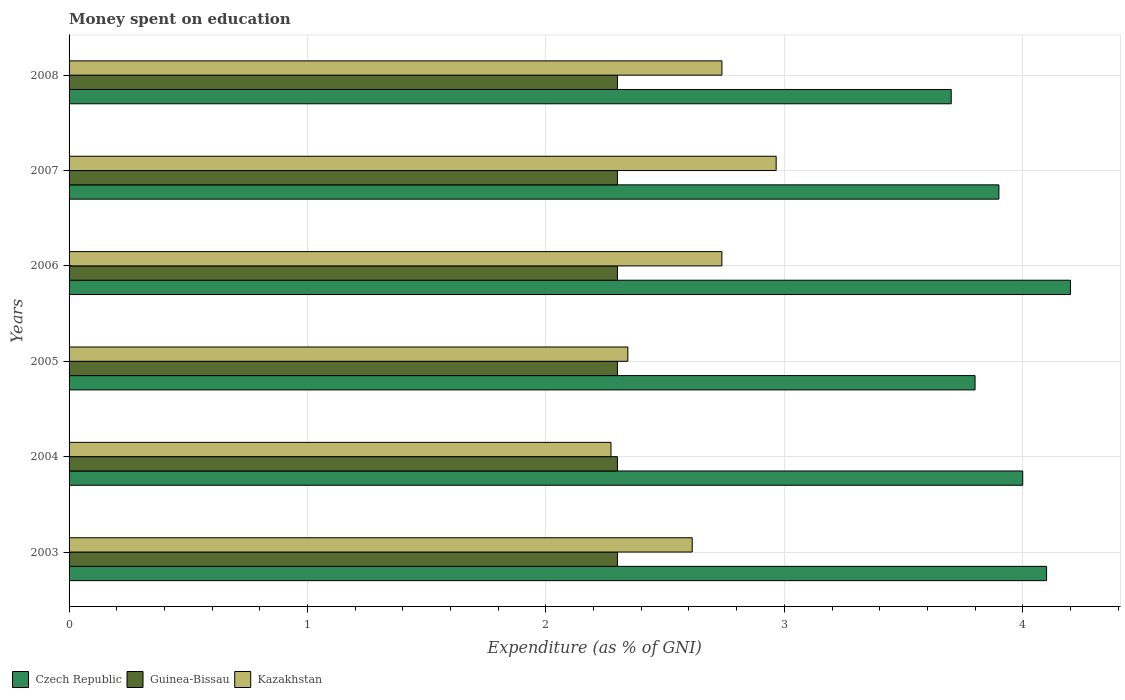How many different coloured bars are there?
Offer a terse response. 3. How many groups of bars are there?
Your answer should be very brief. 6. Are the number of bars on each tick of the Y-axis equal?
Give a very brief answer. Yes. What is the label of the 3rd group of bars from the top?
Your response must be concise. 2006. What is the amount of money spent on education in Czech Republic in 2003?
Your response must be concise. 4.1. In which year was the amount of money spent on education in Guinea-Bissau minimum?
Provide a short and direct response. 2003. What is the difference between the amount of money spent on education in Czech Republic in 2003 and that in 2008?
Offer a terse response. 0.4. What is the difference between the amount of money spent on education in Guinea-Bissau in 2004 and the amount of money spent on education in Kazakhstan in 2006?
Give a very brief answer. -0.44. What is the average amount of money spent on education in Guinea-Bissau per year?
Make the answer very short. 2.3. In the year 2005, what is the difference between the amount of money spent on education in Guinea-Bissau and amount of money spent on education in Czech Republic?
Your answer should be compact. -1.5. In how many years, is the amount of money spent on education in Czech Republic greater than 2.6 %?
Your answer should be compact. 6. What is the ratio of the amount of money spent on education in Guinea-Bissau in 2004 to that in 2006?
Your answer should be very brief. 1. What is the difference between the highest and the second highest amount of money spent on education in Guinea-Bissau?
Make the answer very short. 0. In how many years, is the amount of money spent on education in Czech Republic greater than the average amount of money spent on education in Czech Republic taken over all years?
Your response must be concise. 3. What does the 3rd bar from the top in 2006 represents?
Provide a short and direct response. Czech Republic. What does the 1st bar from the bottom in 2008 represents?
Ensure brevity in your answer.  Czech Republic. How many bars are there?
Keep it short and to the point. 18. Are all the bars in the graph horizontal?
Your answer should be very brief. Yes. What is the difference between two consecutive major ticks on the X-axis?
Your response must be concise. 1. Are the values on the major ticks of X-axis written in scientific E-notation?
Keep it short and to the point. No. Does the graph contain any zero values?
Offer a terse response. No. Where does the legend appear in the graph?
Ensure brevity in your answer.  Bottom left. How many legend labels are there?
Provide a succinct answer. 3. What is the title of the graph?
Ensure brevity in your answer.  Money spent on education. Does "Angola" appear as one of the legend labels in the graph?
Your answer should be very brief. No. What is the label or title of the X-axis?
Give a very brief answer. Expenditure (as % of GNI). What is the label or title of the Y-axis?
Ensure brevity in your answer.  Years. What is the Expenditure (as % of GNI) of Guinea-Bissau in 2003?
Make the answer very short. 2.3. What is the Expenditure (as % of GNI) of Kazakhstan in 2003?
Offer a very short reply. 2.61. What is the Expenditure (as % of GNI) of Czech Republic in 2004?
Offer a very short reply. 4. What is the Expenditure (as % of GNI) of Kazakhstan in 2004?
Your answer should be compact. 2.27. What is the Expenditure (as % of GNI) of Kazakhstan in 2005?
Your answer should be very brief. 2.34. What is the Expenditure (as % of GNI) in Kazakhstan in 2006?
Give a very brief answer. 2.74. What is the Expenditure (as % of GNI) in Czech Republic in 2007?
Provide a succinct answer. 3.9. What is the Expenditure (as % of GNI) of Guinea-Bissau in 2007?
Give a very brief answer. 2.3. What is the Expenditure (as % of GNI) of Kazakhstan in 2007?
Keep it short and to the point. 2.97. What is the Expenditure (as % of GNI) of Kazakhstan in 2008?
Give a very brief answer. 2.74. Across all years, what is the maximum Expenditure (as % of GNI) of Czech Republic?
Provide a succinct answer. 4.2. Across all years, what is the maximum Expenditure (as % of GNI) of Kazakhstan?
Your response must be concise. 2.97. Across all years, what is the minimum Expenditure (as % of GNI) of Kazakhstan?
Give a very brief answer. 2.27. What is the total Expenditure (as % of GNI) in Czech Republic in the graph?
Make the answer very short. 23.7. What is the total Expenditure (as % of GNI) of Kazakhstan in the graph?
Keep it short and to the point. 15.67. What is the difference between the Expenditure (as % of GNI) in Czech Republic in 2003 and that in 2004?
Offer a very short reply. 0.1. What is the difference between the Expenditure (as % of GNI) of Guinea-Bissau in 2003 and that in 2004?
Offer a very short reply. 0. What is the difference between the Expenditure (as % of GNI) in Kazakhstan in 2003 and that in 2004?
Your answer should be very brief. 0.34. What is the difference between the Expenditure (as % of GNI) of Czech Republic in 2003 and that in 2005?
Your response must be concise. 0.3. What is the difference between the Expenditure (as % of GNI) of Kazakhstan in 2003 and that in 2005?
Give a very brief answer. 0.27. What is the difference between the Expenditure (as % of GNI) of Czech Republic in 2003 and that in 2006?
Give a very brief answer. -0.1. What is the difference between the Expenditure (as % of GNI) of Kazakhstan in 2003 and that in 2006?
Ensure brevity in your answer.  -0.12. What is the difference between the Expenditure (as % of GNI) of Guinea-Bissau in 2003 and that in 2007?
Offer a terse response. 0. What is the difference between the Expenditure (as % of GNI) of Kazakhstan in 2003 and that in 2007?
Offer a very short reply. -0.35. What is the difference between the Expenditure (as % of GNI) in Czech Republic in 2003 and that in 2008?
Offer a terse response. 0.4. What is the difference between the Expenditure (as % of GNI) in Kazakhstan in 2003 and that in 2008?
Give a very brief answer. -0.12. What is the difference between the Expenditure (as % of GNI) in Czech Republic in 2004 and that in 2005?
Offer a very short reply. 0.2. What is the difference between the Expenditure (as % of GNI) in Guinea-Bissau in 2004 and that in 2005?
Your answer should be compact. 0. What is the difference between the Expenditure (as % of GNI) of Kazakhstan in 2004 and that in 2005?
Your response must be concise. -0.07. What is the difference between the Expenditure (as % of GNI) of Czech Republic in 2004 and that in 2006?
Keep it short and to the point. -0.2. What is the difference between the Expenditure (as % of GNI) of Kazakhstan in 2004 and that in 2006?
Your answer should be very brief. -0.47. What is the difference between the Expenditure (as % of GNI) in Czech Republic in 2004 and that in 2007?
Provide a succinct answer. 0.1. What is the difference between the Expenditure (as % of GNI) of Guinea-Bissau in 2004 and that in 2007?
Your answer should be very brief. 0. What is the difference between the Expenditure (as % of GNI) in Kazakhstan in 2004 and that in 2007?
Make the answer very short. -0.69. What is the difference between the Expenditure (as % of GNI) of Guinea-Bissau in 2004 and that in 2008?
Your answer should be very brief. 0. What is the difference between the Expenditure (as % of GNI) in Kazakhstan in 2004 and that in 2008?
Provide a succinct answer. -0.47. What is the difference between the Expenditure (as % of GNI) in Czech Republic in 2005 and that in 2006?
Keep it short and to the point. -0.4. What is the difference between the Expenditure (as % of GNI) in Kazakhstan in 2005 and that in 2006?
Provide a short and direct response. -0.39. What is the difference between the Expenditure (as % of GNI) in Czech Republic in 2005 and that in 2007?
Your answer should be very brief. -0.1. What is the difference between the Expenditure (as % of GNI) in Kazakhstan in 2005 and that in 2007?
Provide a succinct answer. -0.62. What is the difference between the Expenditure (as % of GNI) of Guinea-Bissau in 2005 and that in 2008?
Your response must be concise. 0. What is the difference between the Expenditure (as % of GNI) of Kazakhstan in 2005 and that in 2008?
Provide a succinct answer. -0.39. What is the difference between the Expenditure (as % of GNI) in Guinea-Bissau in 2006 and that in 2007?
Provide a short and direct response. 0. What is the difference between the Expenditure (as % of GNI) of Kazakhstan in 2006 and that in 2007?
Provide a succinct answer. -0.23. What is the difference between the Expenditure (as % of GNI) of Czech Republic in 2006 and that in 2008?
Ensure brevity in your answer.  0.5. What is the difference between the Expenditure (as % of GNI) of Guinea-Bissau in 2006 and that in 2008?
Offer a very short reply. 0. What is the difference between the Expenditure (as % of GNI) of Kazakhstan in 2006 and that in 2008?
Provide a short and direct response. -0. What is the difference between the Expenditure (as % of GNI) of Guinea-Bissau in 2007 and that in 2008?
Your answer should be very brief. 0. What is the difference between the Expenditure (as % of GNI) in Kazakhstan in 2007 and that in 2008?
Give a very brief answer. 0.23. What is the difference between the Expenditure (as % of GNI) in Czech Republic in 2003 and the Expenditure (as % of GNI) in Guinea-Bissau in 2004?
Provide a short and direct response. 1.8. What is the difference between the Expenditure (as % of GNI) in Czech Republic in 2003 and the Expenditure (as % of GNI) in Kazakhstan in 2004?
Give a very brief answer. 1.83. What is the difference between the Expenditure (as % of GNI) in Guinea-Bissau in 2003 and the Expenditure (as % of GNI) in Kazakhstan in 2004?
Give a very brief answer. 0.03. What is the difference between the Expenditure (as % of GNI) of Czech Republic in 2003 and the Expenditure (as % of GNI) of Guinea-Bissau in 2005?
Provide a short and direct response. 1.8. What is the difference between the Expenditure (as % of GNI) of Czech Republic in 2003 and the Expenditure (as % of GNI) of Kazakhstan in 2005?
Provide a succinct answer. 1.76. What is the difference between the Expenditure (as % of GNI) of Guinea-Bissau in 2003 and the Expenditure (as % of GNI) of Kazakhstan in 2005?
Your response must be concise. -0.04. What is the difference between the Expenditure (as % of GNI) in Czech Republic in 2003 and the Expenditure (as % of GNI) in Kazakhstan in 2006?
Keep it short and to the point. 1.36. What is the difference between the Expenditure (as % of GNI) of Guinea-Bissau in 2003 and the Expenditure (as % of GNI) of Kazakhstan in 2006?
Offer a terse response. -0.44. What is the difference between the Expenditure (as % of GNI) of Czech Republic in 2003 and the Expenditure (as % of GNI) of Kazakhstan in 2007?
Offer a very short reply. 1.13. What is the difference between the Expenditure (as % of GNI) in Guinea-Bissau in 2003 and the Expenditure (as % of GNI) in Kazakhstan in 2007?
Give a very brief answer. -0.67. What is the difference between the Expenditure (as % of GNI) in Czech Republic in 2003 and the Expenditure (as % of GNI) in Guinea-Bissau in 2008?
Keep it short and to the point. 1.8. What is the difference between the Expenditure (as % of GNI) in Czech Republic in 2003 and the Expenditure (as % of GNI) in Kazakhstan in 2008?
Provide a succinct answer. 1.36. What is the difference between the Expenditure (as % of GNI) in Guinea-Bissau in 2003 and the Expenditure (as % of GNI) in Kazakhstan in 2008?
Your answer should be compact. -0.44. What is the difference between the Expenditure (as % of GNI) in Czech Republic in 2004 and the Expenditure (as % of GNI) in Guinea-Bissau in 2005?
Provide a short and direct response. 1.7. What is the difference between the Expenditure (as % of GNI) in Czech Republic in 2004 and the Expenditure (as % of GNI) in Kazakhstan in 2005?
Provide a short and direct response. 1.66. What is the difference between the Expenditure (as % of GNI) in Guinea-Bissau in 2004 and the Expenditure (as % of GNI) in Kazakhstan in 2005?
Your answer should be very brief. -0.04. What is the difference between the Expenditure (as % of GNI) of Czech Republic in 2004 and the Expenditure (as % of GNI) of Guinea-Bissau in 2006?
Offer a very short reply. 1.7. What is the difference between the Expenditure (as % of GNI) of Czech Republic in 2004 and the Expenditure (as % of GNI) of Kazakhstan in 2006?
Offer a very short reply. 1.26. What is the difference between the Expenditure (as % of GNI) of Guinea-Bissau in 2004 and the Expenditure (as % of GNI) of Kazakhstan in 2006?
Make the answer very short. -0.44. What is the difference between the Expenditure (as % of GNI) in Czech Republic in 2004 and the Expenditure (as % of GNI) in Kazakhstan in 2007?
Your answer should be compact. 1.03. What is the difference between the Expenditure (as % of GNI) of Guinea-Bissau in 2004 and the Expenditure (as % of GNI) of Kazakhstan in 2007?
Give a very brief answer. -0.67. What is the difference between the Expenditure (as % of GNI) of Czech Republic in 2004 and the Expenditure (as % of GNI) of Guinea-Bissau in 2008?
Provide a succinct answer. 1.7. What is the difference between the Expenditure (as % of GNI) of Czech Republic in 2004 and the Expenditure (as % of GNI) of Kazakhstan in 2008?
Offer a terse response. 1.26. What is the difference between the Expenditure (as % of GNI) of Guinea-Bissau in 2004 and the Expenditure (as % of GNI) of Kazakhstan in 2008?
Make the answer very short. -0.44. What is the difference between the Expenditure (as % of GNI) of Czech Republic in 2005 and the Expenditure (as % of GNI) of Kazakhstan in 2006?
Your answer should be compact. 1.06. What is the difference between the Expenditure (as % of GNI) of Guinea-Bissau in 2005 and the Expenditure (as % of GNI) of Kazakhstan in 2006?
Your answer should be very brief. -0.44. What is the difference between the Expenditure (as % of GNI) in Czech Republic in 2005 and the Expenditure (as % of GNI) in Guinea-Bissau in 2007?
Offer a very short reply. 1.5. What is the difference between the Expenditure (as % of GNI) in Czech Republic in 2005 and the Expenditure (as % of GNI) in Kazakhstan in 2007?
Provide a succinct answer. 0.83. What is the difference between the Expenditure (as % of GNI) in Guinea-Bissau in 2005 and the Expenditure (as % of GNI) in Kazakhstan in 2007?
Offer a terse response. -0.67. What is the difference between the Expenditure (as % of GNI) in Czech Republic in 2005 and the Expenditure (as % of GNI) in Kazakhstan in 2008?
Ensure brevity in your answer.  1.06. What is the difference between the Expenditure (as % of GNI) in Guinea-Bissau in 2005 and the Expenditure (as % of GNI) in Kazakhstan in 2008?
Provide a succinct answer. -0.44. What is the difference between the Expenditure (as % of GNI) of Czech Republic in 2006 and the Expenditure (as % of GNI) of Kazakhstan in 2007?
Your response must be concise. 1.23. What is the difference between the Expenditure (as % of GNI) of Guinea-Bissau in 2006 and the Expenditure (as % of GNI) of Kazakhstan in 2007?
Make the answer very short. -0.67. What is the difference between the Expenditure (as % of GNI) in Czech Republic in 2006 and the Expenditure (as % of GNI) in Guinea-Bissau in 2008?
Make the answer very short. 1.9. What is the difference between the Expenditure (as % of GNI) of Czech Republic in 2006 and the Expenditure (as % of GNI) of Kazakhstan in 2008?
Keep it short and to the point. 1.46. What is the difference between the Expenditure (as % of GNI) in Guinea-Bissau in 2006 and the Expenditure (as % of GNI) in Kazakhstan in 2008?
Make the answer very short. -0.44. What is the difference between the Expenditure (as % of GNI) in Czech Republic in 2007 and the Expenditure (as % of GNI) in Kazakhstan in 2008?
Provide a succinct answer. 1.16. What is the difference between the Expenditure (as % of GNI) of Guinea-Bissau in 2007 and the Expenditure (as % of GNI) of Kazakhstan in 2008?
Provide a succinct answer. -0.44. What is the average Expenditure (as % of GNI) of Czech Republic per year?
Offer a very short reply. 3.95. What is the average Expenditure (as % of GNI) of Guinea-Bissau per year?
Provide a succinct answer. 2.3. What is the average Expenditure (as % of GNI) of Kazakhstan per year?
Provide a succinct answer. 2.61. In the year 2003, what is the difference between the Expenditure (as % of GNI) of Czech Republic and Expenditure (as % of GNI) of Guinea-Bissau?
Give a very brief answer. 1.8. In the year 2003, what is the difference between the Expenditure (as % of GNI) in Czech Republic and Expenditure (as % of GNI) in Kazakhstan?
Your response must be concise. 1.49. In the year 2003, what is the difference between the Expenditure (as % of GNI) in Guinea-Bissau and Expenditure (as % of GNI) in Kazakhstan?
Provide a short and direct response. -0.31. In the year 2004, what is the difference between the Expenditure (as % of GNI) in Czech Republic and Expenditure (as % of GNI) in Guinea-Bissau?
Your answer should be very brief. 1.7. In the year 2004, what is the difference between the Expenditure (as % of GNI) of Czech Republic and Expenditure (as % of GNI) of Kazakhstan?
Your answer should be compact. 1.73. In the year 2004, what is the difference between the Expenditure (as % of GNI) in Guinea-Bissau and Expenditure (as % of GNI) in Kazakhstan?
Your answer should be very brief. 0.03. In the year 2005, what is the difference between the Expenditure (as % of GNI) of Czech Republic and Expenditure (as % of GNI) of Kazakhstan?
Your answer should be very brief. 1.46. In the year 2005, what is the difference between the Expenditure (as % of GNI) in Guinea-Bissau and Expenditure (as % of GNI) in Kazakhstan?
Offer a terse response. -0.04. In the year 2006, what is the difference between the Expenditure (as % of GNI) in Czech Republic and Expenditure (as % of GNI) in Guinea-Bissau?
Provide a succinct answer. 1.9. In the year 2006, what is the difference between the Expenditure (as % of GNI) of Czech Republic and Expenditure (as % of GNI) of Kazakhstan?
Your response must be concise. 1.46. In the year 2006, what is the difference between the Expenditure (as % of GNI) in Guinea-Bissau and Expenditure (as % of GNI) in Kazakhstan?
Your response must be concise. -0.44. In the year 2007, what is the difference between the Expenditure (as % of GNI) in Czech Republic and Expenditure (as % of GNI) in Kazakhstan?
Offer a very short reply. 0.93. In the year 2007, what is the difference between the Expenditure (as % of GNI) in Guinea-Bissau and Expenditure (as % of GNI) in Kazakhstan?
Offer a terse response. -0.67. In the year 2008, what is the difference between the Expenditure (as % of GNI) of Czech Republic and Expenditure (as % of GNI) of Kazakhstan?
Offer a terse response. 0.96. In the year 2008, what is the difference between the Expenditure (as % of GNI) in Guinea-Bissau and Expenditure (as % of GNI) in Kazakhstan?
Offer a very short reply. -0.44. What is the ratio of the Expenditure (as % of GNI) of Czech Republic in 2003 to that in 2004?
Offer a very short reply. 1.02. What is the ratio of the Expenditure (as % of GNI) of Guinea-Bissau in 2003 to that in 2004?
Offer a very short reply. 1. What is the ratio of the Expenditure (as % of GNI) of Kazakhstan in 2003 to that in 2004?
Keep it short and to the point. 1.15. What is the ratio of the Expenditure (as % of GNI) in Czech Republic in 2003 to that in 2005?
Provide a short and direct response. 1.08. What is the ratio of the Expenditure (as % of GNI) in Guinea-Bissau in 2003 to that in 2005?
Give a very brief answer. 1. What is the ratio of the Expenditure (as % of GNI) in Kazakhstan in 2003 to that in 2005?
Your answer should be compact. 1.12. What is the ratio of the Expenditure (as % of GNI) of Czech Republic in 2003 to that in 2006?
Your response must be concise. 0.98. What is the ratio of the Expenditure (as % of GNI) in Guinea-Bissau in 2003 to that in 2006?
Your answer should be very brief. 1. What is the ratio of the Expenditure (as % of GNI) of Kazakhstan in 2003 to that in 2006?
Provide a succinct answer. 0.95. What is the ratio of the Expenditure (as % of GNI) in Czech Republic in 2003 to that in 2007?
Make the answer very short. 1.05. What is the ratio of the Expenditure (as % of GNI) of Guinea-Bissau in 2003 to that in 2007?
Give a very brief answer. 1. What is the ratio of the Expenditure (as % of GNI) in Kazakhstan in 2003 to that in 2007?
Offer a very short reply. 0.88. What is the ratio of the Expenditure (as % of GNI) of Czech Republic in 2003 to that in 2008?
Your answer should be compact. 1.11. What is the ratio of the Expenditure (as % of GNI) of Guinea-Bissau in 2003 to that in 2008?
Your answer should be very brief. 1. What is the ratio of the Expenditure (as % of GNI) of Kazakhstan in 2003 to that in 2008?
Your answer should be compact. 0.95. What is the ratio of the Expenditure (as % of GNI) of Czech Republic in 2004 to that in 2005?
Keep it short and to the point. 1.05. What is the ratio of the Expenditure (as % of GNI) in Kazakhstan in 2004 to that in 2005?
Ensure brevity in your answer.  0.97. What is the ratio of the Expenditure (as % of GNI) in Czech Republic in 2004 to that in 2006?
Make the answer very short. 0.95. What is the ratio of the Expenditure (as % of GNI) in Guinea-Bissau in 2004 to that in 2006?
Keep it short and to the point. 1. What is the ratio of the Expenditure (as % of GNI) in Kazakhstan in 2004 to that in 2006?
Your answer should be compact. 0.83. What is the ratio of the Expenditure (as % of GNI) in Czech Republic in 2004 to that in 2007?
Offer a very short reply. 1.03. What is the ratio of the Expenditure (as % of GNI) of Guinea-Bissau in 2004 to that in 2007?
Offer a terse response. 1. What is the ratio of the Expenditure (as % of GNI) of Kazakhstan in 2004 to that in 2007?
Ensure brevity in your answer.  0.77. What is the ratio of the Expenditure (as % of GNI) in Czech Republic in 2004 to that in 2008?
Give a very brief answer. 1.08. What is the ratio of the Expenditure (as % of GNI) of Guinea-Bissau in 2004 to that in 2008?
Provide a succinct answer. 1. What is the ratio of the Expenditure (as % of GNI) of Kazakhstan in 2004 to that in 2008?
Offer a very short reply. 0.83. What is the ratio of the Expenditure (as % of GNI) in Czech Republic in 2005 to that in 2006?
Provide a succinct answer. 0.9. What is the ratio of the Expenditure (as % of GNI) in Kazakhstan in 2005 to that in 2006?
Your response must be concise. 0.86. What is the ratio of the Expenditure (as % of GNI) of Czech Republic in 2005 to that in 2007?
Give a very brief answer. 0.97. What is the ratio of the Expenditure (as % of GNI) in Kazakhstan in 2005 to that in 2007?
Keep it short and to the point. 0.79. What is the ratio of the Expenditure (as % of GNI) in Kazakhstan in 2005 to that in 2008?
Offer a terse response. 0.86. What is the ratio of the Expenditure (as % of GNI) of Kazakhstan in 2006 to that in 2007?
Offer a very short reply. 0.92. What is the ratio of the Expenditure (as % of GNI) in Czech Republic in 2006 to that in 2008?
Keep it short and to the point. 1.14. What is the ratio of the Expenditure (as % of GNI) in Guinea-Bissau in 2006 to that in 2008?
Your response must be concise. 1. What is the ratio of the Expenditure (as % of GNI) in Czech Republic in 2007 to that in 2008?
Provide a succinct answer. 1.05. What is the ratio of the Expenditure (as % of GNI) in Kazakhstan in 2007 to that in 2008?
Your answer should be very brief. 1.08. What is the difference between the highest and the second highest Expenditure (as % of GNI) in Czech Republic?
Your answer should be compact. 0.1. What is the difference between the highest and the second highest Expenditure (as % of GNI) of Guinea-Bissau?
Give a very brief answer. 0. What is the difference between the highest and the second highest Expenditure (as % of GNI) of Kazakhstan?
Your response must be concise. 0.23. What is the difference between the highest and the lowest Expenditure (as % of GNI) of Kazakhstan?
Your answer should be compact. 0.69. 